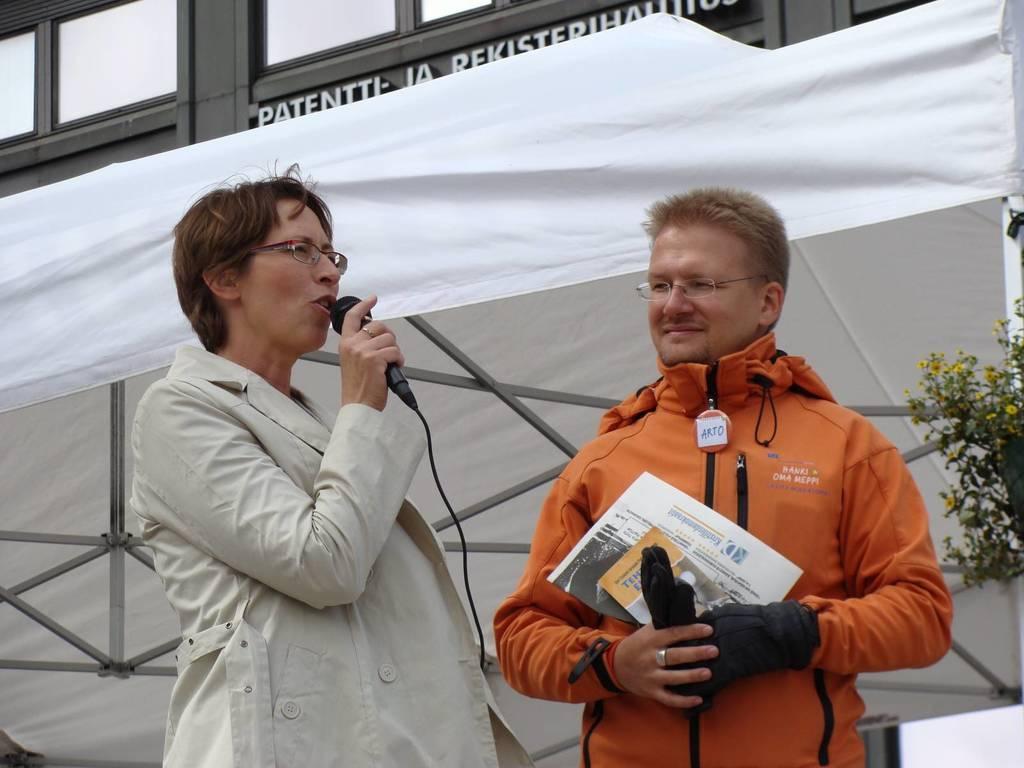Please provide a concise description of this image. As we can see in the image there is a building, cloth, plant and two persons standing. The man on the right side is wearing orange color jacket and holding newspaper. The woman standing on the left side is holding mic. 